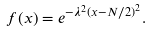Convert formula to latex. <formula><loc_0><loc_0><loc_500><loc_500>f ( x ) = e ^ { - \lambda ^ { 2 } \left ( x - N / 2 \right ) ^ { 2 } } .</formula> 